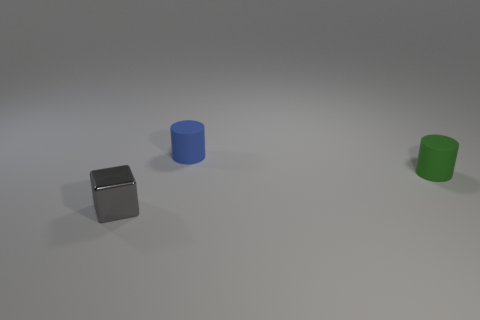What is the color of the other thing that is the same shape as the small blue thing?
Your answer should be compact. Green. Is there any other thing that is the same color as the metallic block?
Your answer should be compact. No. What number of other objects are the same material as the tiny blue cylinder?
Give a very brief answer. 1. The shiny block has what size?
Provide a short and direct response. Small. Are there any other things of the same shape as the gray metal thing?
Ensure brevity in your answer.  No. How many objects are metal objects or small objects to the right of the gray object?
Your answer should be very brief. 3. What color is the small rubber cylinder that is to the left of the tiny green thing?
Give a very brief answer. Blue. There is a matte object that is behind the green cylinder; is it the same size as the rubber object in front of the tiny blue thing?
Ensure brevity in your answer.  Yes. Are there any yellow matte balls of the same size as the blue matte thing?
Your answer should be very brief. No. How many tiny cylinders are behind the tiny thing on the left side of the blue cylinder?
Provide a short and direct response. 2. 